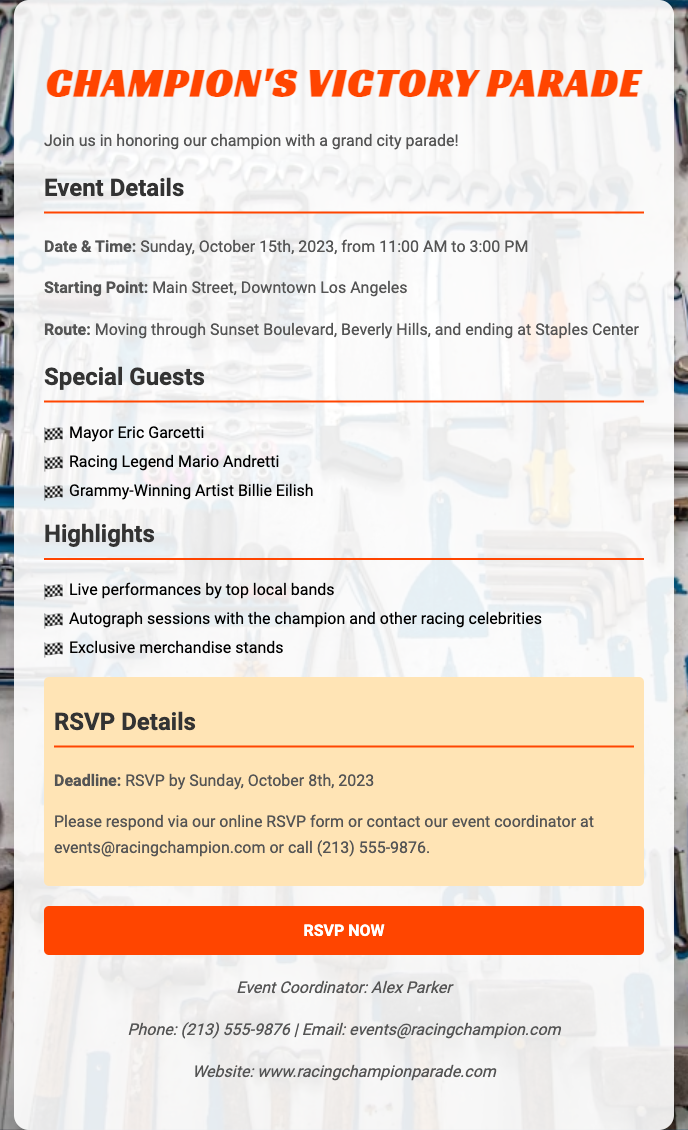what is the date of the event? The date of the event is specifically mentioned in the document as Sunday, October 15th, 2023.
Answer: Sunday, October 15th, 2023 what is the starting point of the parade? The document states that the starting point of the parade is Main Street, Downtown Los Angeles.
Answer: Main Street, Downtown Los Angeles who is one of the special guests attending? The document lists several special guests, including Mayor Eric Garcetti, which can be referenced directly.
Answer: Mayor Eric Garcetti what time does the parade start? The time at which the parade begins is indicated in the event details section as 11:00 AM.
Answer: 11:00 AM how can I RSVP for the event? The document provides RSVP methods, stating that attendees can respond via an online form or contact the event coordinator directly.
Answer: Online RSVP form or contact what is the deadline for RSVPs? The document specifies that the RSVP deadline is Sunday, October 8th, 2023.
Answer: Sunday, October 8th, 2023 who is the event coordinator? The document names Alex Parker as the event coordinator, which is a specific piece of information.
Answer: Alex Parker what type of performances will be at the event? The document mentions live performances by top local bands as a highlight of the event.
Answer: Live performances by top local bands 